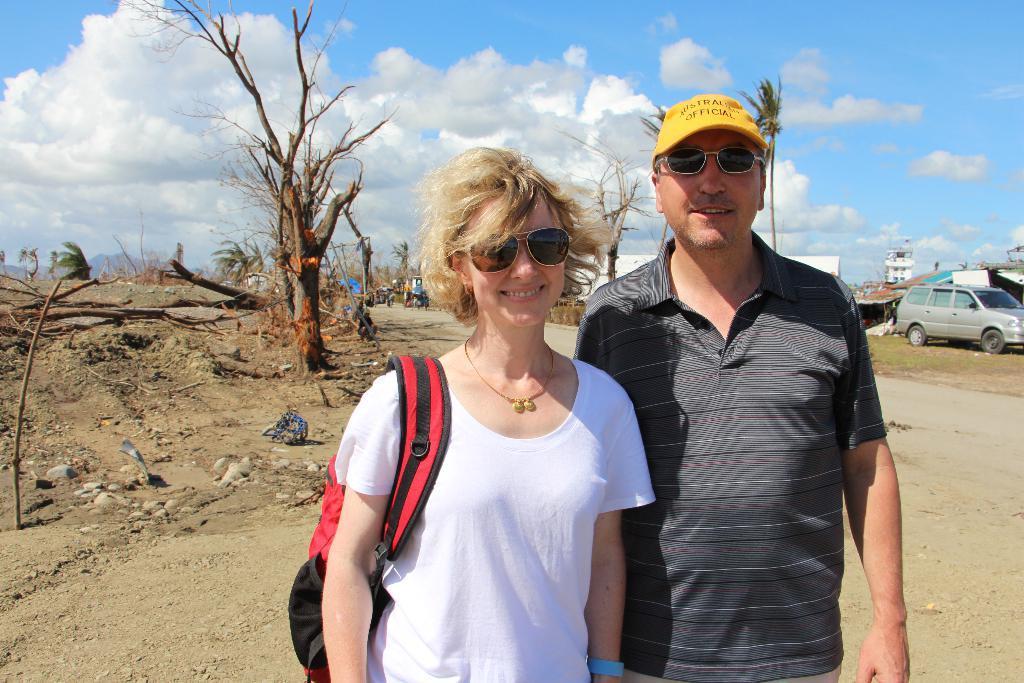Please provide a concise description of this image. Here in this picture we can see a couple standing on the ground and we can see both of them are wearing goggles and smiling and we can see the woman is carrying a bag and the man is wearing cap on him and behind him we can see some vehicles present on the ground and we can also see tents and sheds present and we can also see some part of ground is covered with grass and we can see plants and trees present and we can see other people also present in the far and we can see the clouds in the sky. 